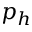Convert formula to latex. <formula><loc_0><loc_0><loc_500><loc_500>p _ { h }</formula> 